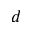Convert formula to latex. <formula><loc_0><loc_0><loc_500><loc_500>d</formula> 